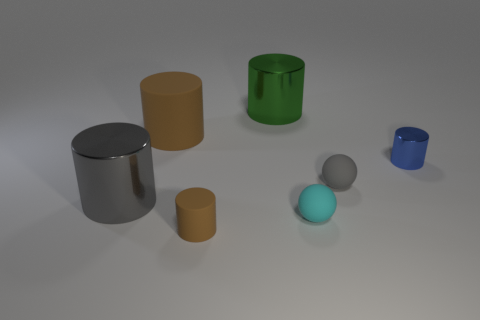Subtract 2 cylinders. How many cylinders are left? 3 Subtract all green cylinders. How many cylinders are left? 4 Subtract all big brown matte cylinders. How many cylinders are left? 4 Subtract all gray cylinders. Subtract all red blocks. How many cylinders are left? 4 Add 2 large purple metallic blocks. How many objects exist? 9 Subtract all spheres. How many objects are left? 5 Subtract 1 blue cylinders. How many objects are left? 6 Subtract all large brown matte cylinders. Subtract all tiny blue metallic cylinders. How many objects are left? 5 Add 1 rubber cylinders. How many rubber cylinders are left? 3 Add 7 small shiny objects. How many small shiny objects exist? 8 